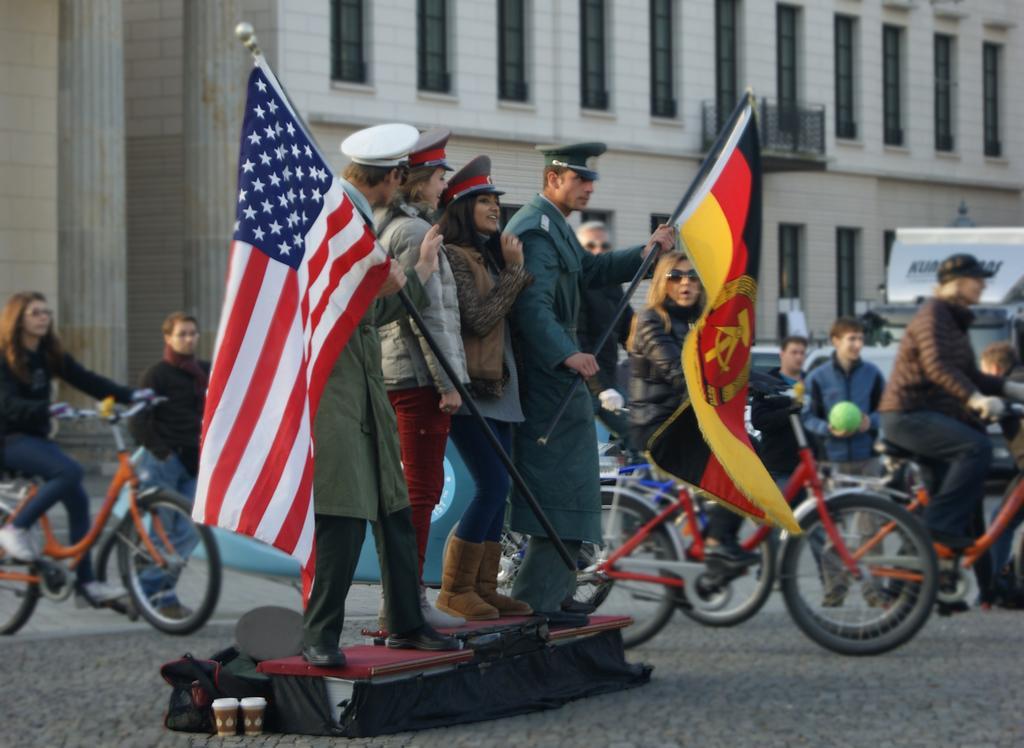Could you give a brief overview of what you see in this image? In this image we can see few persons are standing on an object which is on the road and among them two persons are holding flag poles in their hands and there are objects on the road. In the background we can see few persons are standing and few persons are riding bicycles, building, windows, railing, pillars and vehicles. 